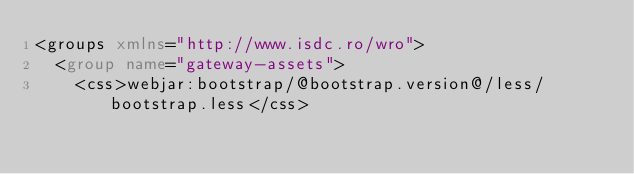<code> <loc_0><loc_0><loc_500><loc_500><_XML_><groups xmlns="http://www.isdc.ro/wro">
  <group name="gateway-assets">
    <css>webjar:bootstrap/@bootstrap.version@/less/bootstrap.less</css></code> 